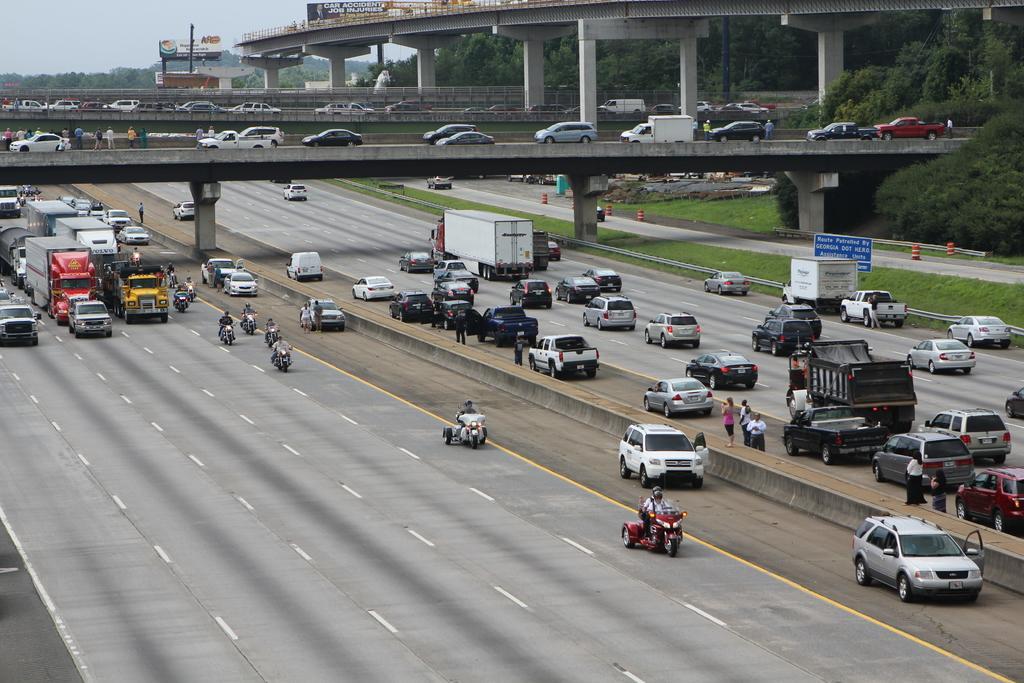Describe this image in one or two sentences. In this picture there are cars and trucks in the center of the image, on a road and there is a bridge at the top side of the image, on which there are cars, there are trees on the right side of the image. 